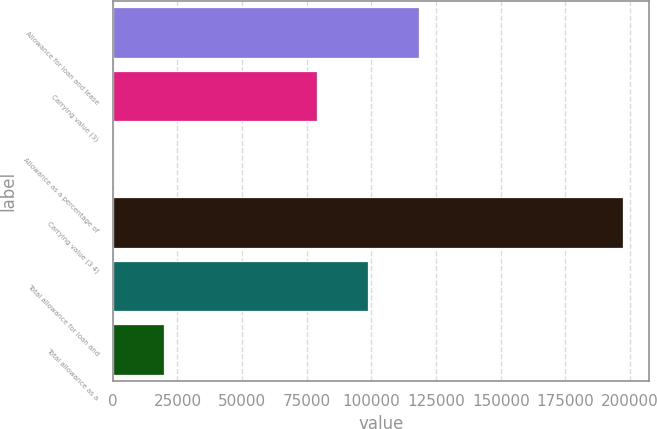Convert chart. <chart><loc_0><loc_0><loc_500><loc_500><bar_chart><fcel>Allowance for loan and lease<fcel>Carrying value (3)<fcel>Allowance as a percentage of<fcel>Carrying value (3 4)<fcel>Total allowance for loan and<fcel>Total allowance as a<nl><fcel>118483<fcel>78989<fcel>1.66<fcel>197470<fcel>98735.8<fcel>19748.5<nl></chart> 